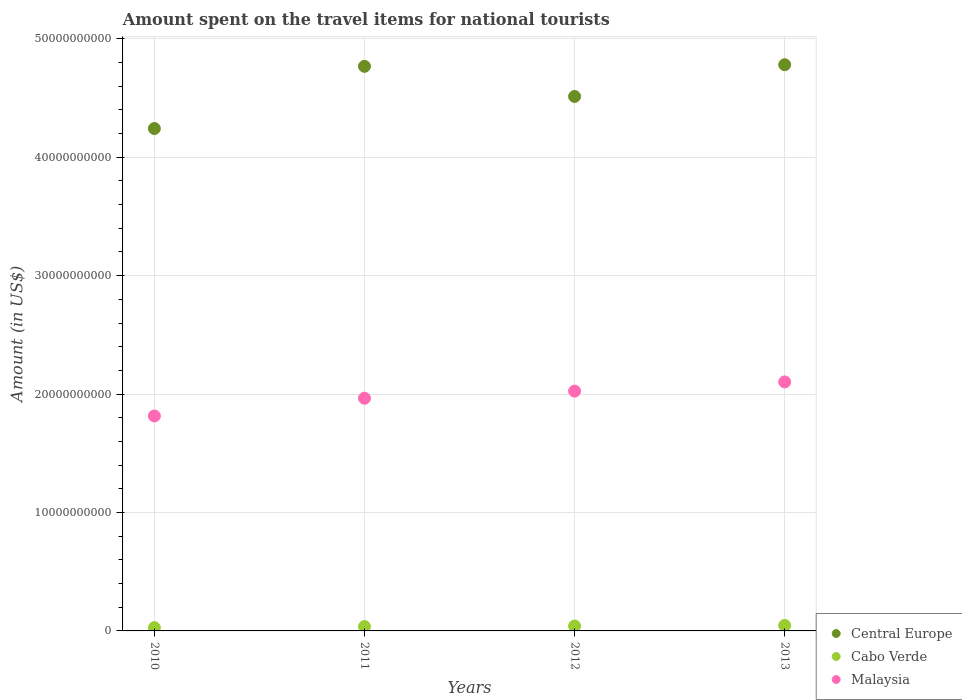What is the amount spent on the travel items for national tourists in Cabo Verde in 2011?
Keep it short and to the point. 3.68e+08. Across all years, what is the maximum amount spent on the travel items for national tourists in Malaysia?
Provide a succinct answer. 2.10e+1. Across all years, what is the minimum amount spent on the travel items for national tourists in Malaysia?
Your response must be concise. 1.82e+1. In which year was the amount spent on the travel items for national tourists in Central Europe minimum?
Ensure brevity in your answer.  2010. What is the total amount spent on the travel items for national tourists in Central Europe in the graph?
Offer a terse response. 1.83e+11. What is the difference between the amount spent on the travel items for national tourists in Malaysia in 2010 and that in 2013?
Your response must be concise. -2.87e+09. What is the difference between the amount spent on the travel items for national tourists in Central Europe in 2013 and the amount spent on the travel items for national tourists in Malaysia in 2012?
Offer a very short reply. 2.76e+1. What is the average amount spent on the travel items for national tourists in Central Europe per year?
Provide a succinct answer. 4.58e+1. In the year 2010, what is the difference between the amount spent on the travel items for national tourists in Central Europe and amount spent on the travel items for national tourists in Cabo Verde?
Your answer should be compact. 4.21e+1. In how many years, is the amount spent on the travel items for national tourists in Central Europe greater than 44000000000 US$?
Your answer should be compact. 3. What is the ratio of the amount spent on the travel items for national tourists in Malaysia in 2010 to that in 2011?
Give a very brief answer. 0.92. What is the difference between the highest and the second highest amount spent on the travel items for national tourists in Cabo Verde?
Ensure brevity in your answer.  4.90e+07. What is the difference between the highest and the lowest amount spent on the travel items for national tourists in Cabo Verde?
Provide a short and direct response. 1.85e+08. Is it the case that in every year, the sum of the amount spent on the travel items for national tourists in Malaysia and amount spent on the travel items for national tourists in Cabo Verde  is greater than the amount spent on the travel items for national tourists in Central Europe?
Your answer should be very brief. No. Is the amount spent on the travel items for national tourists in Central Europe strictly less than the amount spent on the travel items for national tourists in Malaysia over the years?
Give a very brief answer. No. How many dotlines are there?
Your answer should be very brief. 3. How many years are there in the graph?
Keep it short and to the point. 4. What is the difference between two consecutive major ticks on the Y-axis?
Provide a succinct answer. 1.00e+1. Are the values on the major ticks of Y-axis written in scientific E-notation?
Provide a short and direct response. No. Where does the legend appear in the graph?
Provide a succinct answer. Bottom right. How are the legend labels stacked?
Give a very brief answer. Vertical. What is the title of the graph?
Provide a succinct answer. Amount spent on the travel items for national tourists. Does "Cyprus" appear as one of the legend labels in the graph?
Offer a terse response. No. What is the label or title of the X-axis?
Offer a terse response. Years. What is the label or title of the Y-axis?
Give a very brief answer. Amount (in US$). What is the Amount (in US$) of Central Europe in 2010?
Keep it short and to the point. 4.24e+1. What is the Amount (in US$) of Cabo Verde in 2010?
Ensure brevity in your answer.  2.78e+08. What is the Amount (in US$) in Malaysia in 2010?
Keep it short and to the point. 1.82e+1. What is the Amount (in US$) of Central Europe in 2011?
Make the answer very short. 4.77e+1. What is the Amount (in US$) of Cabo Verde in 2011?
Give a very brief answer. 3.68e+08. What is the Amount (in US$) of Malaysia in 2011?
Your response must be concise. 1.96e+1. What is the Amount (in US$) in Central Europe in 2012?
Provide a short and direct response. 4.51e+1. What is the Amount (in US$) in Cabo Verde in 2012?
Your answer should be very brief. 4.14e+08. What is the Amount (in US$) in Malaysia in 2012?
Give a very brief answer. 2.03e+1. What is the Amount (in US$) of Central Europe in 2013?
Make the answer very short. 4.78e+1. What is the Amount (in US$) of Cabo Verde in 2013?
Your answer should be compact. 4.63e+08. What is the Amount (in US$) of Malaysia in 2013?
Offer a terse response. 2.10e+1. Across all years, what is the maximum Amount (in US$) in Central Europe?
Provide a succinct answer. 4.78e+1. Across all years, what is the maximum Amount (in US$) of Cabo Verde?
Provide a succinct answer. 4.63e+08. Across all years, what is the maximum Amount (in US$) of Malaysia?
Your response must be concise. 2.10e+1. Across all years, what is the minimum Amount (in US$) of Central Europe?
Your answer should be very brief. 4.24e+1. Across all years, what is the minimum Amount (in US$) in Cabo Verde?
Make the answer very short. 2.78e+08. Across all years, what is the minimum Amount (in US$) of Malaysia?
Give a very brief answer. 1.82e+1. What is the total Amount (in US$) in Central Europe in the graph?
Your answer should be compact. 1.83e+11. What is the total Amount (in US$) in Cabo Verde in the graph?
Your response must be concise. 1.52e+09. What is the total Amount (in US$) of Malaysia in the graph?
Your response must be concise. 7.91e+1. What is the difference between the Amount (in US$) in Central Europe in 2010 and that in 2011?
Make the answer very short. -5.25e+09. What is the difference between the Amount (in US$) in Cabo Verde in 2010 and that in 2011?
Ensure brevity in your answer.  -9.00e+07. What is the difference between the Amount (in US$) in Malaysia in 2010 and that in 2011?
Keep it short and to the point. -1.50e+09. What is the difference between the Amount (in US$) in Central Europe in 2010 and that in 2012?
Offer a terse response. -2.71e+09. What is the difference between the Amount (in US$) of Cabo Verde in 2010 and that in 2012?
Your answer should be compact. -1.36e+08. What is the difference between the Amount (in US$) of Malaysia in 2010 and that in 2012?
Ensure brevity in your answer.  -2.10e+09. What is the difference between the Amount (in US$) of Central Europe in 2010 and that in 2013?
Your answer should be compact. -5.39e+09. What is the difference between the Amount (in US$) of Cabo Verde in 2010 and that in 2013?
Offer a terse response. -1.85e+08. What is the difference between the Amount (in US$) of Malaysia in 2010 and that in 2013?
Provide a succinct answer. -2.87e+09. What is the difference between the Amount (in US$) of Central Europe in 2011 and that in 2012?
Your answer should be compact. 2.54e+09. What is the difference between the Amount (in US$) of Cabo Verde in 2011 and that in 2012?
Ensure brevity in your answer.  -4.60e+07. What is the difference between the Amount (in US$) of Malaysia in 2011 and that in 2012?
Give a very brief answer. -6.02e+08. What is the difference between the Amount (in US$) in Central Europe in 2011 and that in 2013?
Your response must be concise. -1.35e+08. What is the difference between the Amount (in US$) of Cabo Verde in 2011 and that in 2013?
Offer a very short reply. -9.50e+07. What is the difference between the Amount (in US$) in Malaysia in 2011 and that in 2013?
Your response must be concise. -1.38e+09. What is the difference between the Amount (in US$) in Central Europe in 2012 and that in 2013?
Your answer should be compact. -2.68e+09. What is the difference between the Amount (in US$) in Cabo Verde in 2012 and that in 2013?
Provide a succinct answer. -4.90e+07. What is the difference between the Amount (in US$) in Malaysia in 2012 and that in 2013?
Provide a succinct answer. -7.75e+08. What is the difference between the Amount (in US$) of Central Europe in 2010 and the Amount (in US$) of Cabo Verde in 2011?
Give a very brief answer. 4.21e+1. What is the difference between the Amount (in US$) of Central Europe in 2010 and the Amount (in US$) of Malaysia in 2011?
Your answer should be very brief. 2.28e+1. What is the difference between the Amount (in US$) in Cabo Verde in 2010 and the Amount (in US$) in Malaysia in 2011?
Your response must be concise. -1.94e+1. What is the difference between the Amount (in US$) in Central Europe in 2010 and the Amount (in US$) in Cabo Verde in 2012?
Ensure brevity in your answer.  4.20e+1. What is the difference between the Amount (in US$) in Central Europe in 2010 and the Amount (in US$) in Malaysia in 2012?
Provide a short and direct response. 2.22e+1. What is the difference between the Amount (in US$) in Cabo Verde in 2010 and the Amount (in US$) in Malaysia in 2012?
Your answer should be compact. -2.00e+1. What is the difference between the Amount (in US$) of Central Europe in 2010 and the Amount (in US$) of Cabo Verde in 2013?
Make the answer very short. 4.20e+1. What is the difference between the Amount (in US$) of Central Europe in 2010 and the Amount (in US$) of Malaysia in 2013?
Your answer should be compact. 2.14e+1. What is the difference between the Amount (in US$) in Cabo Verde in 2010 and the Amount (in US$) in Malaysia in 2013?
Make the answer very short. -2.07e+1. What is the difference between the Amount (in US$) in Central Europe in 2011 and the Amount (in US$) in Cabo Verde in 2012?
Provide a succinct answer. 4.73e+1. What is the difference between the Amount (in US$) in Central Europe in 2011 and the Amount (in US$) in Malaysia in 2012?
Give a very brief answer. 2.74e+1. What is the difference between the Amount (in US$) of Cabo Verde in 2011 and the Amount (in US$) of Malaysia in 2012?
Ensure brevity in your answer.  -1.99e+1. What is the difference between the Amount (in US$) of Central Europe in 2011 and the Amount (in US$) of Cabo Verde in 2013?
Your answer should be compact. 4.72e+1. What is the difference between the Amount (in US$) of Central Europe in 2011 and the Amount (in US$) of Malaysia in 2013?
Offer a terse response. 2.66e+1. What is the difference between the Amount (in US$) in Cabo Verde in 2011 and the Amount (in US$) in Malaysia in 2013?
Your answer should be very brief. -2.07e+1. What is the difference between the Amount (in US$) of Central Europe in 2012 and the Amount (in US$) of Cabo Verde in 2013?
Ensure brevity in your answer.  4.47e+1. What is the difference between the Amount (in US$) in Central Europe in 2012 and the Amount (in US$) in Malaysia in 2013?
Provide a succinct answer. 2.41e+1. What is the difference between the Amount (in US$) of Cabo Verde in 2012 and the Amount (in US$) of Malaysia in 2013?
Provide a short and direct response. -2.06e+1. What is the average Amount (in US$) in Central Europe per year?
Keep it short and to the point. 4.58e+1. What is the average Amount (in US$) of Cabo Verde per year?
Give a very brief answer. 3.81e+08. What is the average Amount (in US$) in Malaysia per year?
Make the answer very short. 1.98e+1. In the year 2010, what is the difference between the Amount (in US$) in Central Europe and Amount (in US$) in Cabo Verde?
Your answer should be very brief. 4.21e+1. In the year 2010, what is the difference between the Amount (in US$) of Central Europe and Amount (in US$) of Malaysia?
Provide a short and direct response. 2.43e+1. In the year 2010, what is the difference between the Amount (in US$) in Cabo Verde and Amount (in US$) in Malaysia?
Your response must be concise. -1.79e+1. In the year 2011, what is the difference between the Amount (in US$) in Central Europe and Amount (in US$) in Cabo Verde?
Provide a short and direct response. 4.73e+1. In the year 2011, what is the difference between the Amount (in US$) in Central Europe and Amount (in US$) in Malaysia?
Provide a short and direct response. 2.80e+1. In the year 2011, what is the difference between the Amount (in US$) in Cabo Verde and Amount (in US$) in Malaysia?
Keep it short and to the point. -1.93e+1. In the year 2012, what is the difference between the Amount (in US$) of Central Europe and Amount (in US$) of Cabo Verde?
Ensure brevity in your answer.  4.47e+1. In the year 2012, what is the difference between the Amount (in US$) in Central Europe and Amount (in US$) in Malaysia?
Offer a very short reply. 2.49e+1. In the year 2012, what is the difference between the Amount (in US$) in Cabo Verde and Amount (in US$) in Malaysia?
Provide a short and direct response. -1.98e+1. In the year 2013, what is the difference between the Amount (in US$) in Central Europe and Amount (in US$) in Cabo Verde?
Your response must be concise. 4.73e+1. In the year 2013, what is the difference between the Amount (in US$) of Central Europe and Amount (in US$) of Malaysia?
Offer a very short reply. 2.68e+1. In the year 2013, what is the difference between the Amount (in US$) in Cabo Verde and Amount (in US$) in Malaysia?
Your response must be concise. -2.06e+1. What is the ratio of the Amount (in US$) of Central Europe in 2010 to that in 2011?
Provide a short and direct response. 0.89. What is the ratio of the Amount (in US$) in Cabo Verde in 2010 to that in 2011?
Your answer should be very brief. 0.76. What is the ratio of the Amount (in US$) in Malaysia in 2010 to that in 2011?
Offer a terse response. 0.92. What is the ratio of the Amount (in US$) of Central Europe in 2010 to that in 2012?
Provide a succinct answer. 0.94. What is the ratio of the Amount (in US$) in Cabo Verde in 2010 to that in 2012?
Offer a very short reply. 0.67. What is the ratio of the Amount (in US$) in Malaysia in 2010 to that in 2012?
Your response must be concise. 0.9. What is the ratio of the Amount (in US$) in Central Europe in 2010 to that in 2013?
Offer a terse response. 0.89. What is the ratio of the Amount (in US$) of Cabo Verde in 2010 to that in 2013?
Keep it short and to the point. 0.6. What is the ratio of the Amount (in US$) in Malaysia in 2010 to that in 2013?
Keep it short and to the point. 0.86. What is the ratio of the Amount (in US$) of Central Europe in 2011 to that in 2012?
Offer a very short reply. 1.06. What is the ratio of the Amount (in US$) in Malaysia in 2011 to that in 2012?
Your answer should be compact. 0.97. What is the ratio of the Amount (in US$) of Cabo Verde in 2011 to that in 2013?
Offer a terse response. 0.79. What is the ratio of the Amount (in US$) of Malaysia in 2011 to that in 2013?
Your answer should be compact. 0.93. What is the ratio of the Amount (in US$) in Central Europe in 2012 to that in 2013?
Provide a succinct answer. 0.94. What is the ratio of the Amount (in US$) of Cabo Verde in 2012 to that in 2013?
Give a very brief answer. 0.89. What is the ratio of the Amount (in US$) in Malaysia in 2012 to that in 2013?
Provide a short and direct response. 0.96. What is the difference between the highest and the second highest Amount (in US$) of Central Europe?
Provide a succinct answer. 1.35e+08. What is the difference between the highest and the second highest Amount (in US$) of Cabo Verde?
Your answer should be compact. 4.90e+07. What is the difference between the highest and the second highest Amount (in US$) of Malaysia?
Ensure brevity in your answer.  7.75e+08. What is the difference between the highest and the lowest Amount (in US$) of Central Europe?
Offer a terse response. 5.39e+09. What is the difference between the highest and the lowest Amount (in US$) in Cabo Verde?
Provide a short and direct response. 1.85e+08. What is the difference between the highest and the lowest Amount (in US$) of Malaysia?
Ensure brevity in your answer.  2.87e+09. 